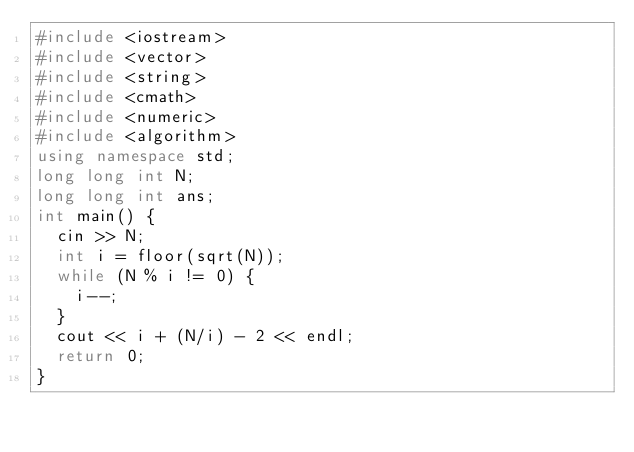Convert code to text. <code><loc_0><loc_0><loc_500><loc_500><_C++_>#include <iostream>
#include <vector>
#include <string>
#include <cmath>
#include <numeric>
#include <algorithm>
using namespace std;
long long int N;
long long int ans;
int main() {
	cin >> N;
	int i = floor(sqrt(N));
	while (N % i != 0) {
		i--;
	}
	cout << i + (N/i) - 2 << endl;
	return 0;
}
</code> 